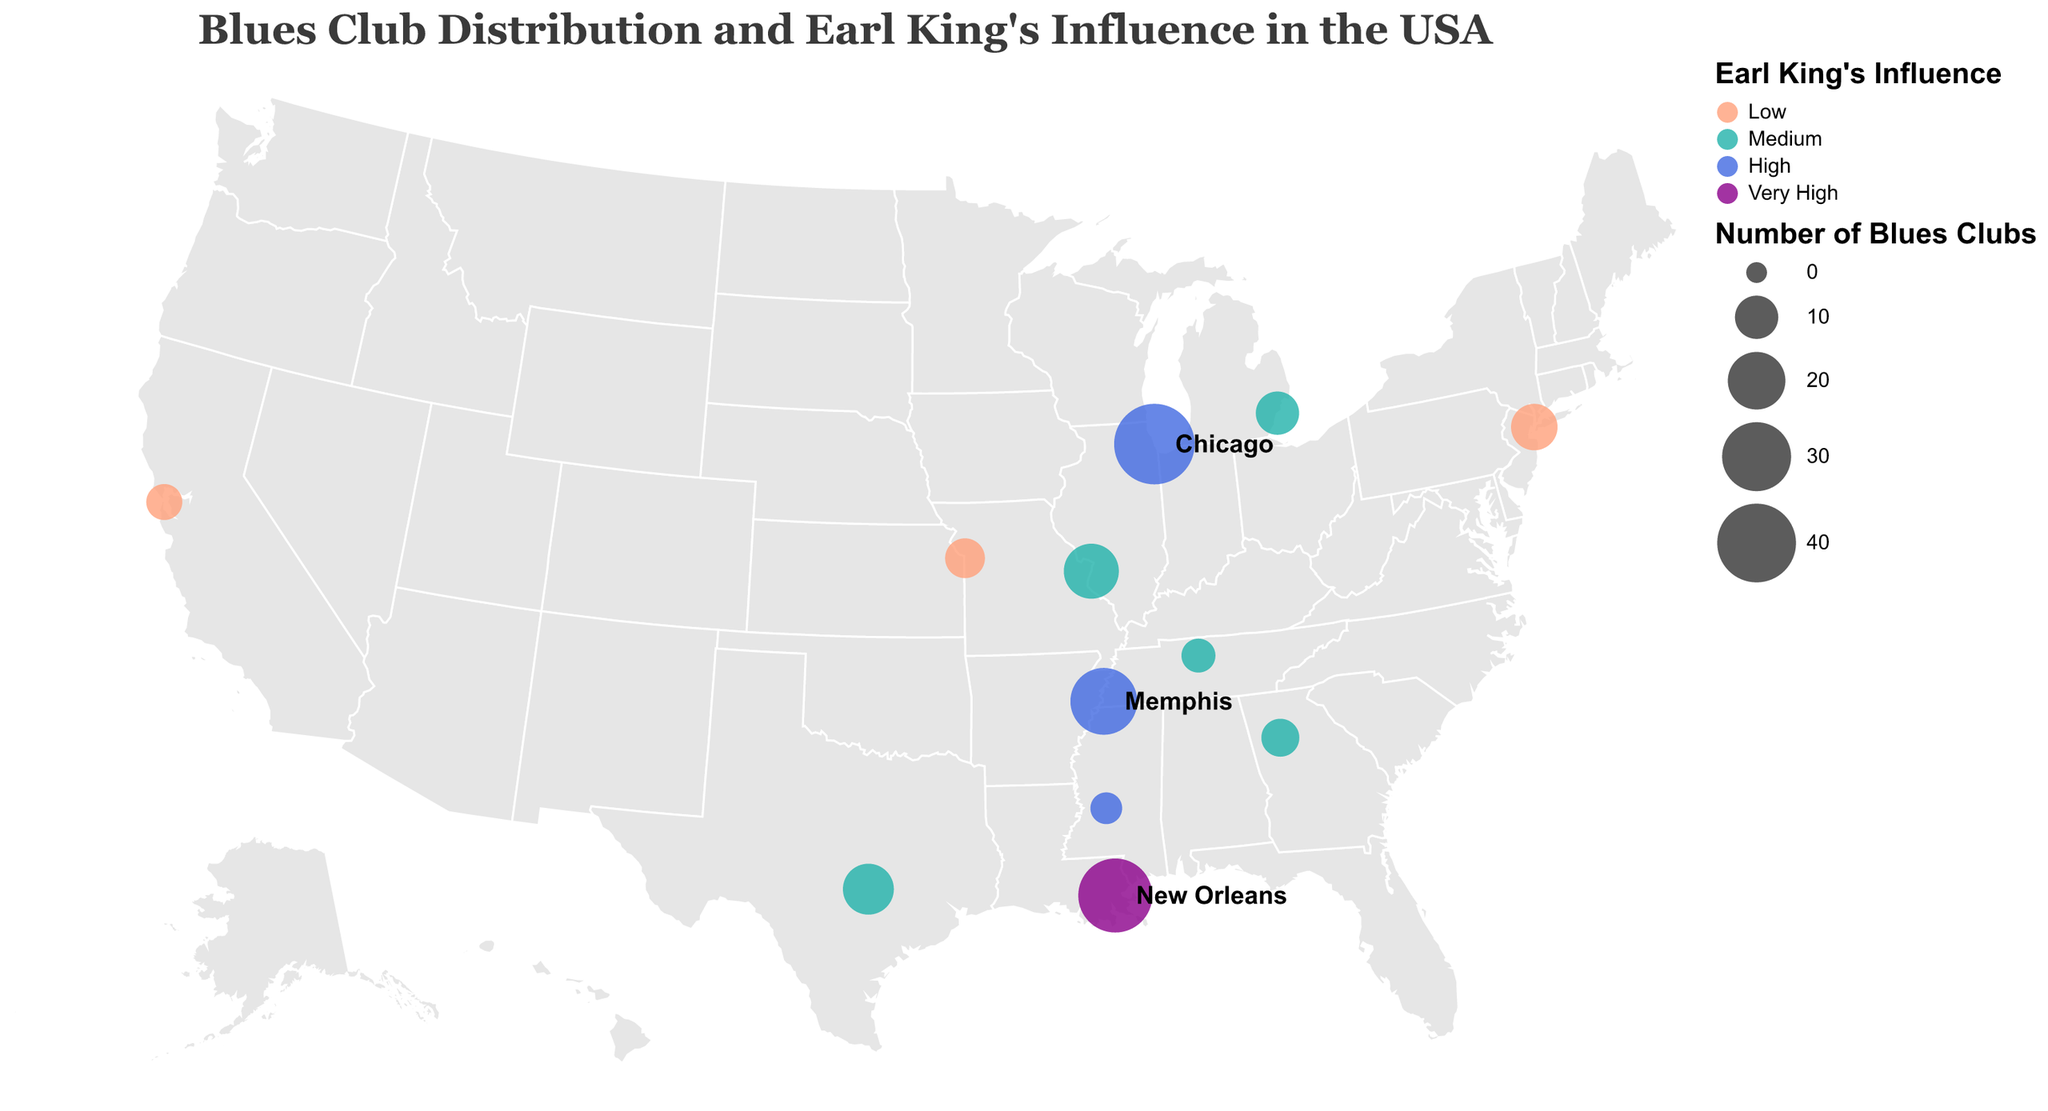Which city has the highest number of blues clubs? The plot highlights the number of blues clubs for each city with a circle's size. The largest circle represents Chicago, indicating it has the highest number of blues clubs.
Answer: Chicago How does Earl King's influence compare between New Orleans and Chicago? The color of the circles represents Earl King's influence. New Orleans is colored in the darkest shade, indicating "Very High" influence, while Chicago is in a medium-dark shade, signifying "High" influence.
Answer: New Orleans has a higher influence Which cities are highlighted as hotspots on the plot? The plot has text labels for certain cities. The labeled cities are Chicago, New Orleans, and Memphis, signifying them as hotspots for blues clubs.
Answer: Chicago, New Orleans, Memphis What is the combined number of blues clubs in cities with "High" Earl King's influence? Cities with "High" influence are Chicago (42 clubs), Memphis (28 clubs), and Jackson (4 clubs). Adding them gives \(42 + 28 + 4 = 74\).
Answer: 74 Which region appears to have more distribution of blues clubs, the Midwest or the South? By visually assessing the number and size of circles in the Midwest (Chicago, St. Louis, Detroit, Kansas City) vs. the South (New Orleans, Memphis, Austin, Atlanta, Jackson), the South appears to have larger and more circles cumulatively.
Answer: The South What is the average number of blues clubs in cities with "Medium" Earl King's influence? Cities with "Medium" influence are St. Louis (18 clubs), Austin (15 clubs), Detroit (10 clubs), Atlanta (7 clubs), and Nashville (5 clubs). The total is \(18 + 15 + 10 + 7 + 5 = 55\) and the average is \(55 / 5 = 11\).
Answer: 11 Which city with "Low" Earl King's influence has the most blues clubs? The cities with "Low" influence are New York City (12 clubs), Kansas City (8 clubs), and San Francisco (6 clubs). New York City has the highest number.
Answer: New York City How many cities on the plot have fewer than 10 blues clubs? The cities with fewer than 10 clubs are Kansas City (8), Atlanta (7), San Francisco (6), Nashville (5), and Jackson (4). There are five cities.
Answer: 5 Which city is the northernmost with "High" Earl King's influence? The cities in the "High" influence category are Chicago, Memphis, and Jackson. Among these, Chicago is the northernmost.
Answer: Chicago 